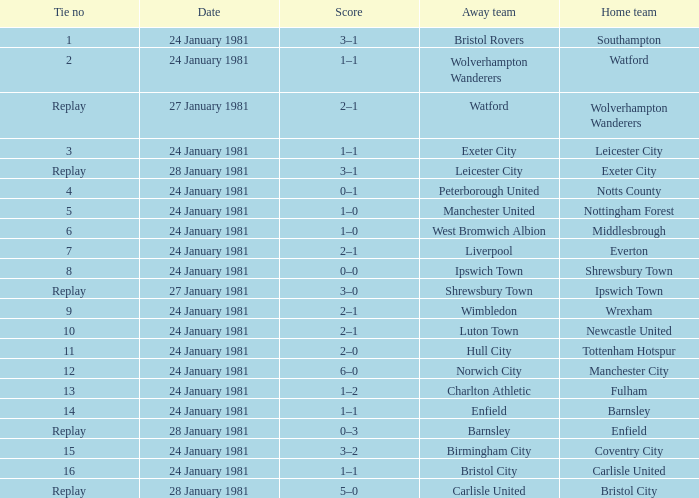What is the score when the tie is 9? 2–1. 